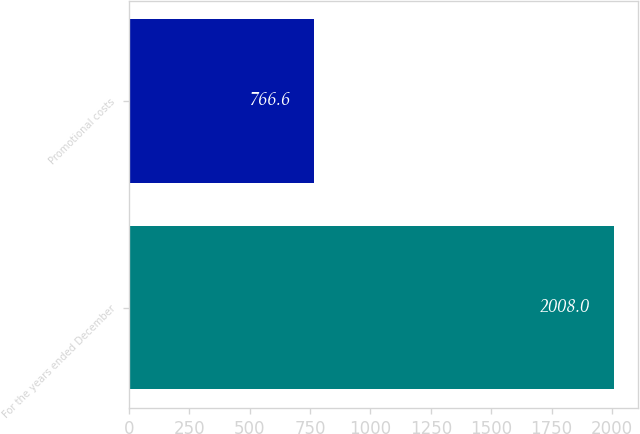<chart> <loc_0><loc_0><loc_500><loc_500><bar_chart><fcel>For the years ended December<fcel>Promotional costs<nl><fcel>2008<fcel>766.6<nl></chart> 